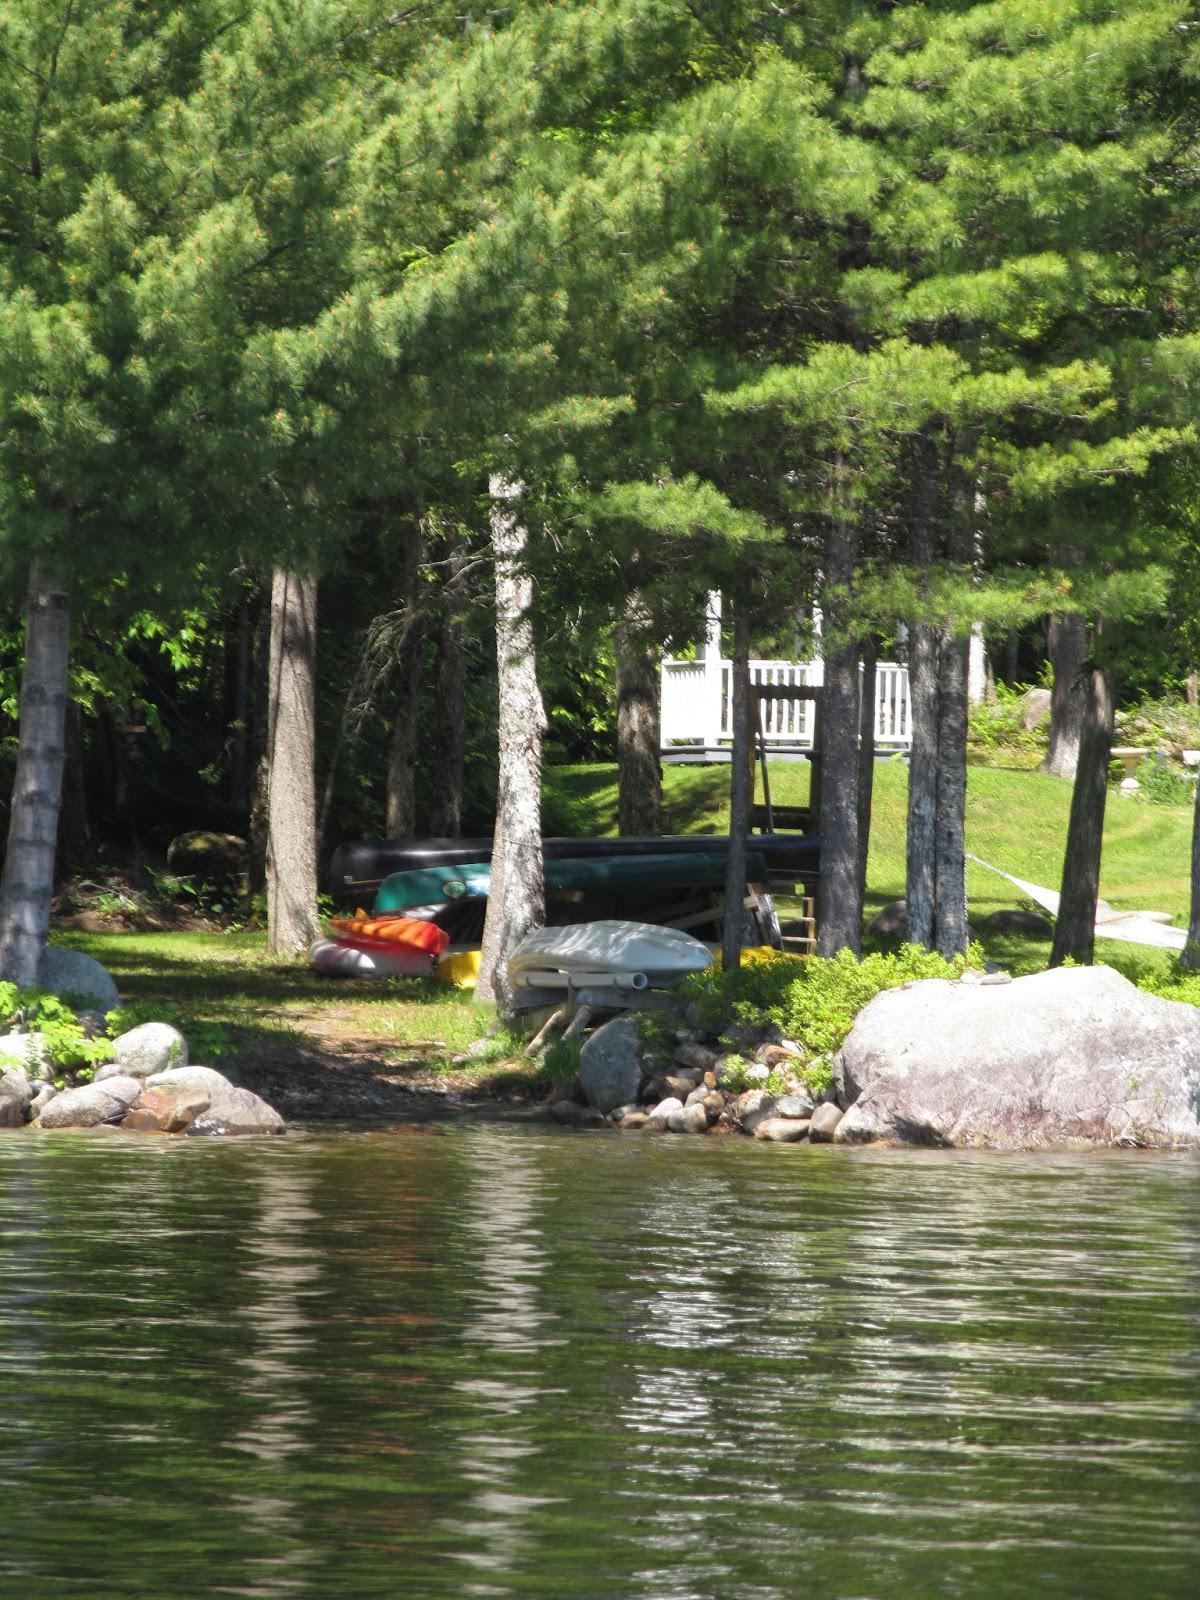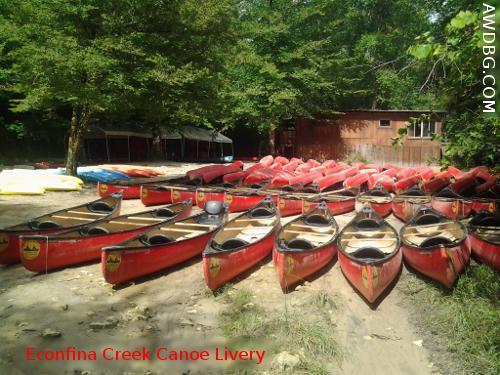The first image is the image on the left, the second image is the image on the right. For the images displayed, is the sentence "There are exactly two boats in the image on the right." factually correct? Answer yes or no. No. The first image is the image on the left, the second image is the image on the right. Analyze the images presented: Is the assertion "One of the images contains exactly two canoes." valid? Answer yes or no. No. 